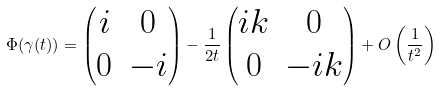Convert formula to latex. <formula><loc_0><loc_0><loc_500><loc_500>\Phi ( \gamma ( t ) ) = \left ( \begin{matrix} i & 0 \\ 0 & - i \end{matrix} \right ) - \frac { 1 } { 2 t } \left ( \begin{matrix} i k & 0 \\ 0 & - i k \end{matrix} \right ) + O \left ( \frac { 1 } { t ^ { 2 } } \right )</formula> 